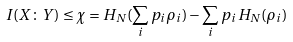Convert formula to latex. <formula><loc_0><loc_0><loc_500><loc_500>I ( X \colon Y ) \leq \chi = H _ { N } ( \sum _ { i } p _ { i } \rho _ { i } ) - \sum _ { i } p _ { i } H _ { N } ( \rho _ { i } )</formula> 